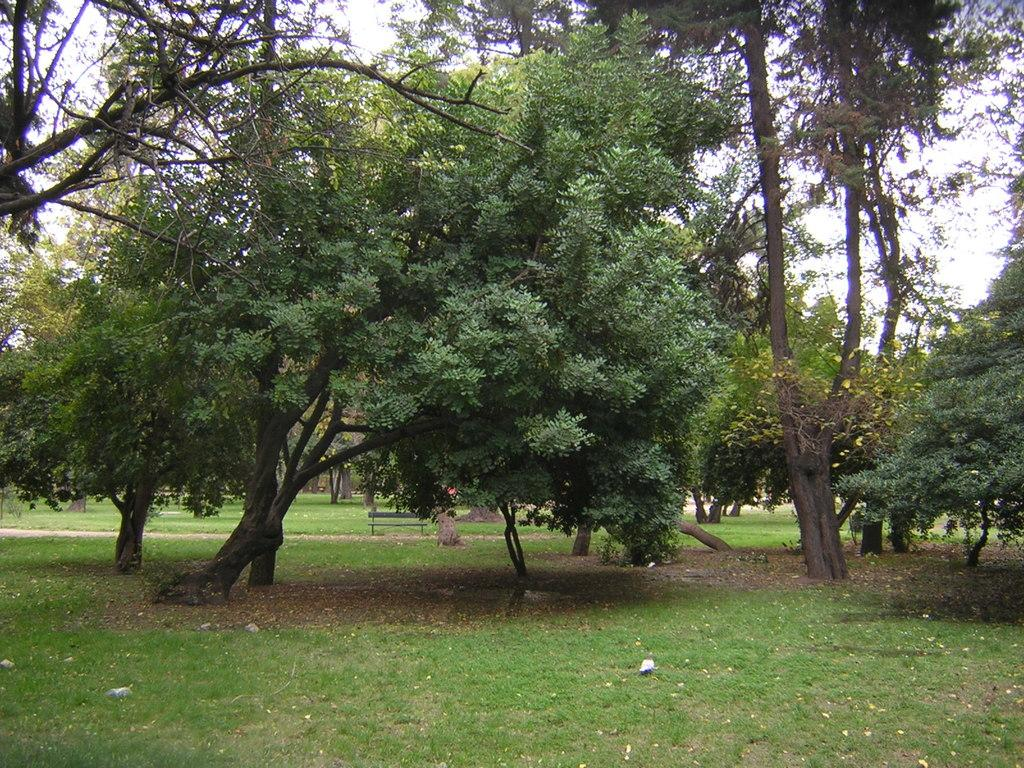What type of vegetation can be seen in the image? There are trees in the image. What type of seating is present in the image? There is a bench in the image. What type of animal can be seen in the image? There is a bird in the image. What is visible in the background of the image? The sky is visible in the background of the image. What type of washing machine is visible in the image? There is no washing machine present in the image. What type of fight is taking place in the image? There is no fight present in the image. 